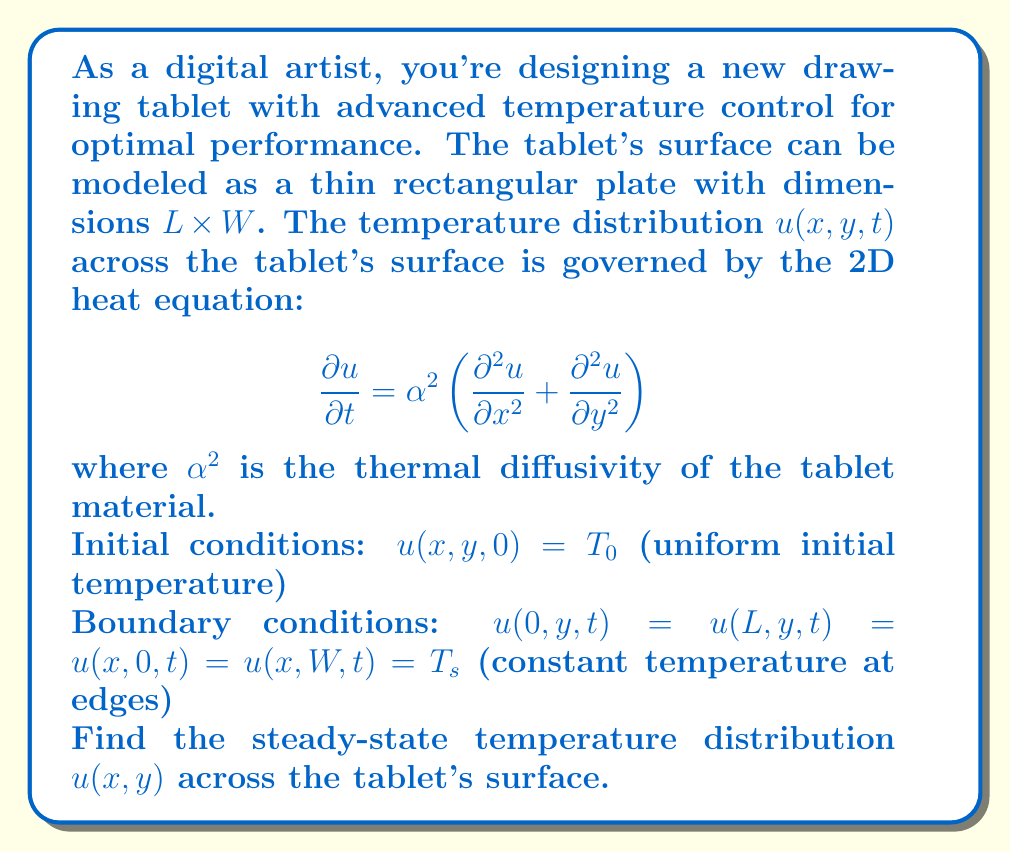Teach me how to tackle this problem. To solve this problem, we'll follow these steps:

1) For the steady-state solution, the temperature doesn't change with time, so $\frac{\partial u}{\partial t} = 0$. The heat equation reduces to:

   $$\frac{\partial^2 u}{\partial x^2} + \frac{\partial^2 u}{\partial y^2} = 0$$

   This is Laplace's equation in 2D.

2) We can solve this using separation of variables. Let $u(x,y) = X(x)Y(y)$.

3) Substituting into Laplace's equation:

   $$Y\frac{d^2X}{dx^2} + X\frac{d^2Y}{dy^2} = 0$$

4) Dividing by $XY$:

   $$\frac{1}{X}\frac{d^2X}{dx^2} = -\frac{1}{Y}\frac{d^2Y}{dy^2} = -\lambda^2$$

   where $\lambda$ is a constant.

5) This gives us two ODEs:
   
   $$\frac{d^2X}{dx^2} + \lambda^2X = 0$$
   $$\frac{d^2Y}{dy^2} - \lambda^2Y = 0$$

6) The general solutions are:
   
   $$X(x) = A\sin(\lambda x) + B\cos(\lambda x)$$
   $$Y(y) = C\sinh(\lambda y) + D\cosh(\lambda y)$$

7) Applying the boundary conditions:
   
   $u(0,y) = u(L,y) = T_s$ implies $B = T_s$ and $\lambda_n = \frac{n\pi}{L}$ where $n = 1,2,3,...$
   
   $u(x,0) = u(x,W) = T_s$ implies $D = T_s$

8) The solution that satisfies all boundary conditions is:

   $$u(x,y) = T_s + \sum_{n=1}^{\infty} A_n \sin\left(\frac{n\pi x}{L}\right)\left[\sinh\left(\frac{n\pi y}{L}\right) - \sinh\left(\frac{n\pi(W-y)}{L}\right)\right]$$

9) The coefficients $A_n$ can be determined using the initial condition, but for the steady-state solution, we don't need to consider the initial condition.

Therefore, this is the general form of the steady-state temperature distribution across the tablet's surface.
Answer: The steady-state temperature distribution across the tablet's surface is:

$$u(x,y) = T_s + \sum_{n=1}^{\infty} A_n \sin\left(\frac{n\pi x}{L}\right)\left[\sinh\left(\frac{n\pi y}{L}\right) - \sinh\left(\frac{n\pi(W-y)}{L}\right)\right]$$

where $T_s$ is the temperature at the edges, $L$ and $W$ are the length and width of the tablet, and $A_n$ are constants determined by the specific initial conditions. 